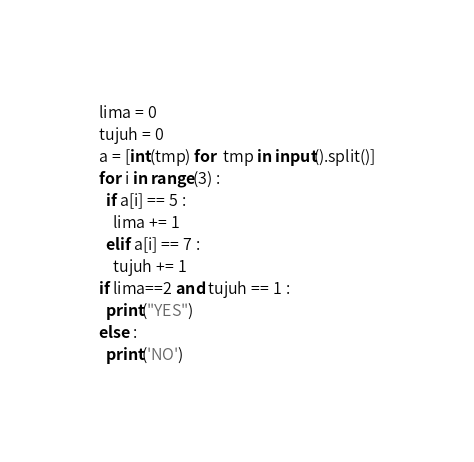Convert code to text. <code><loc_0><loc_0><loc_500><loc_500><_Python_>lima = 0
tujuh = 0
a = [int(tmp) for  tmp in input().split()]
for i in range(3) :
  if a[i] == 5 :
    lima += 1
  elif a[i] == 7 :
    tujuh += 1
if lima==2 and tujuh == 1 :
  print("YES")
else :
  print('NO')</code> 